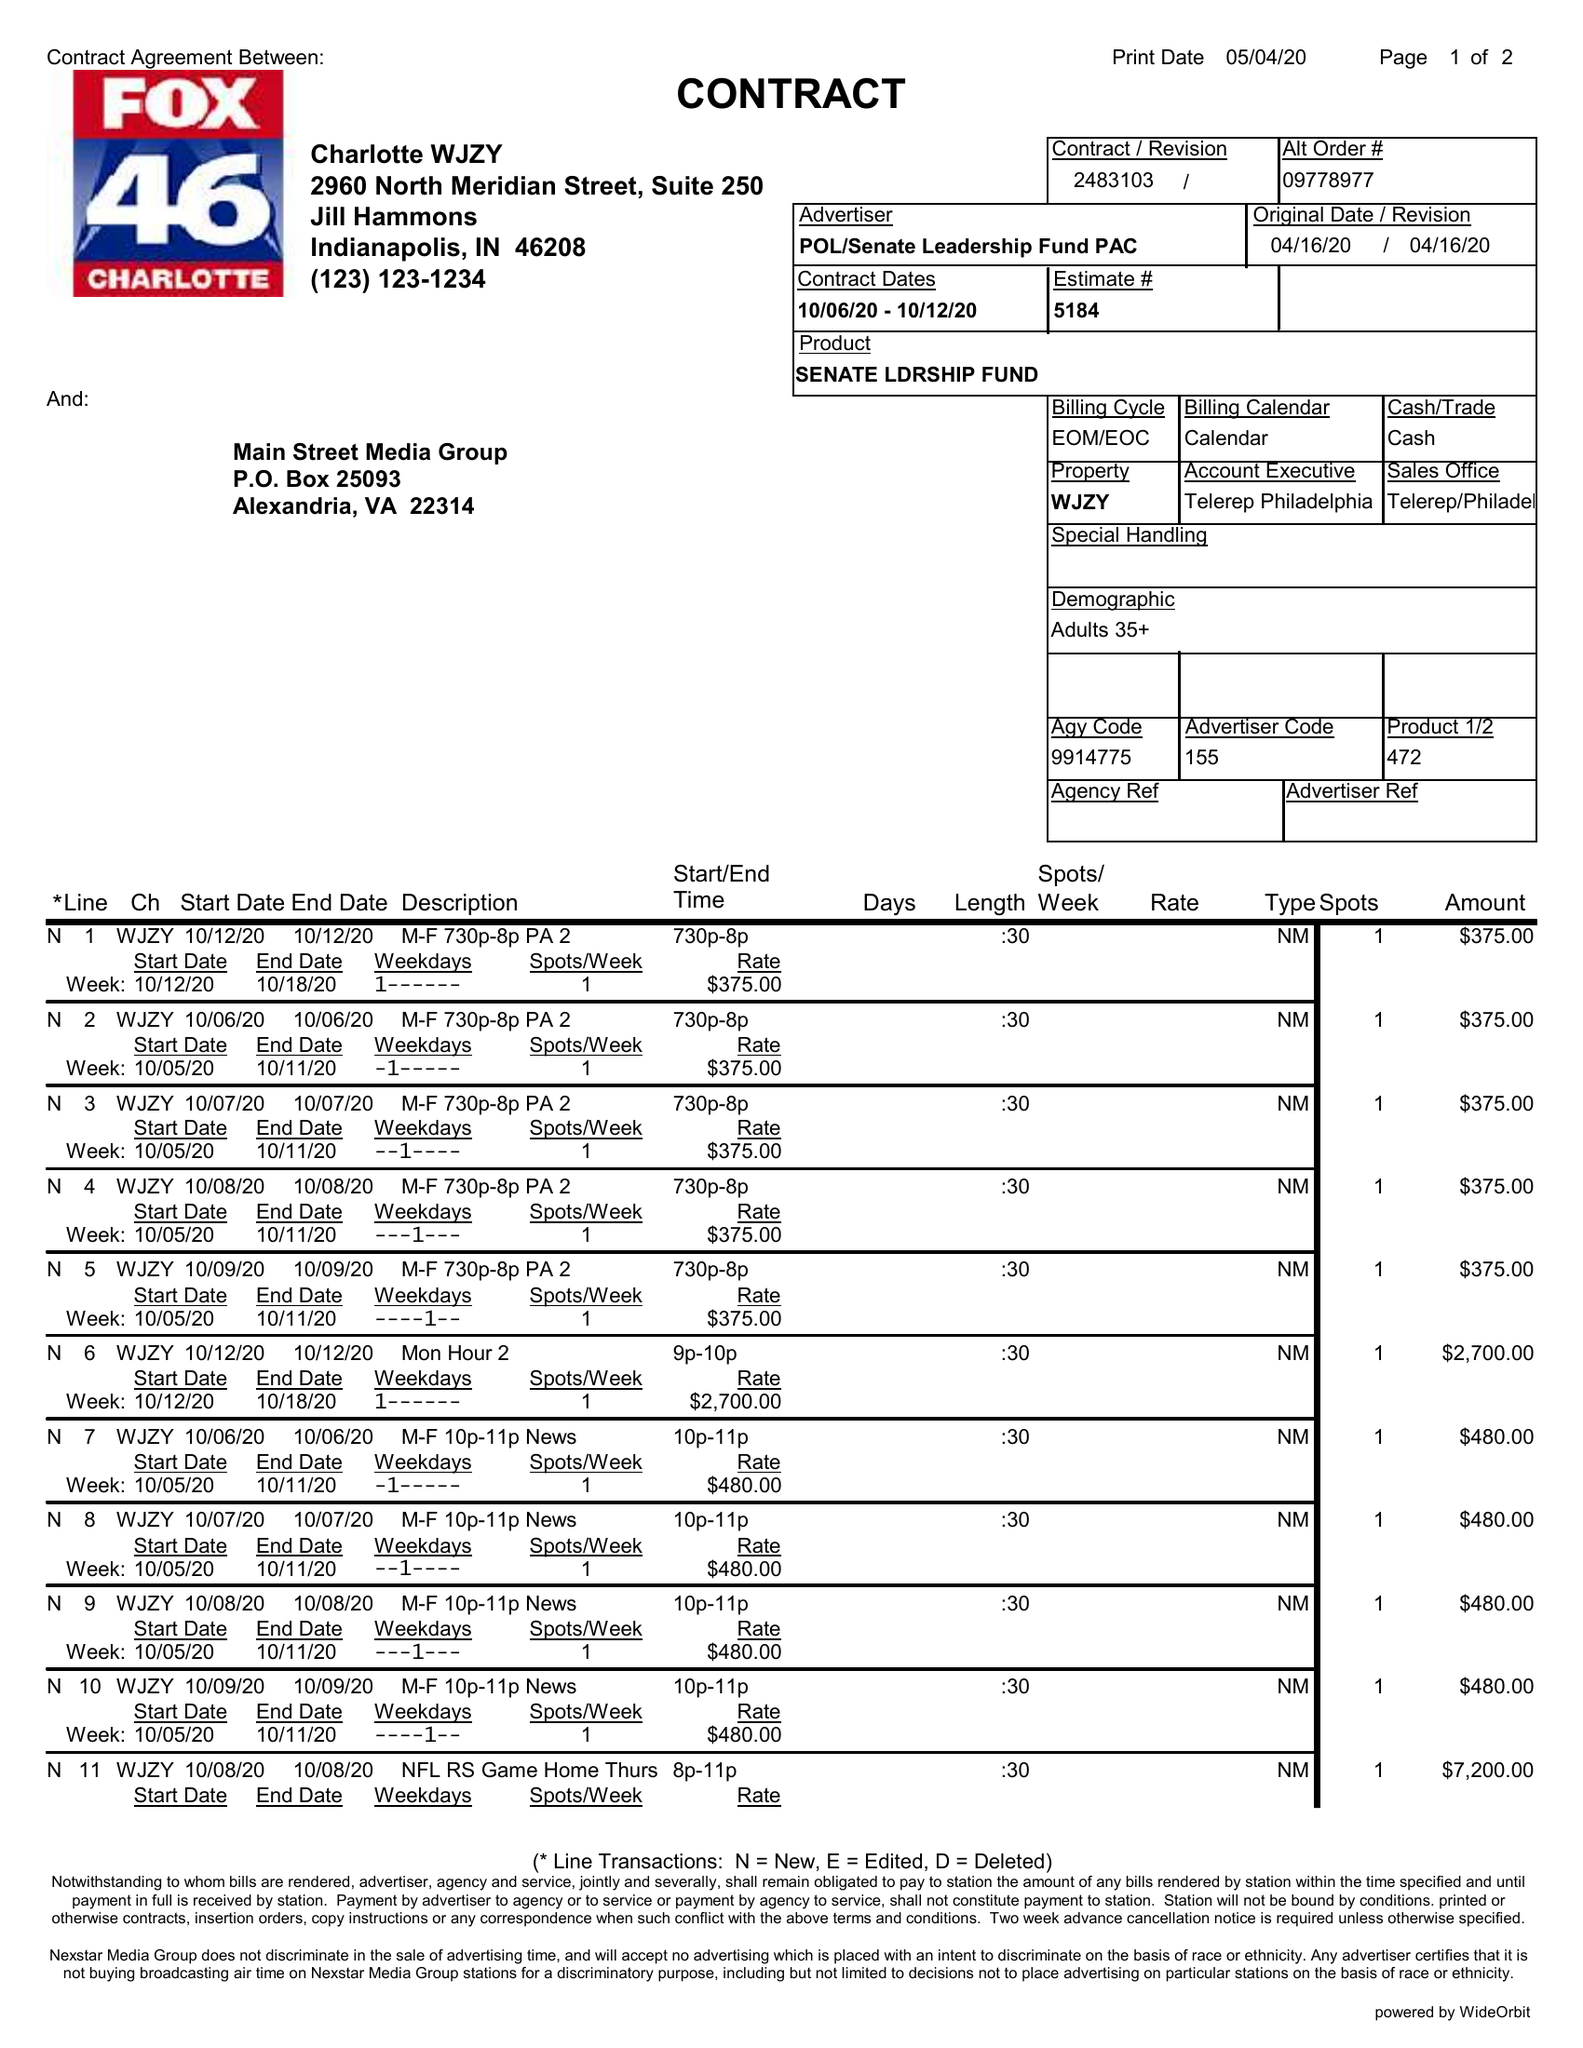What is the value for the flight_from?
Answer the question using a single word or phrase. 10/06/20 